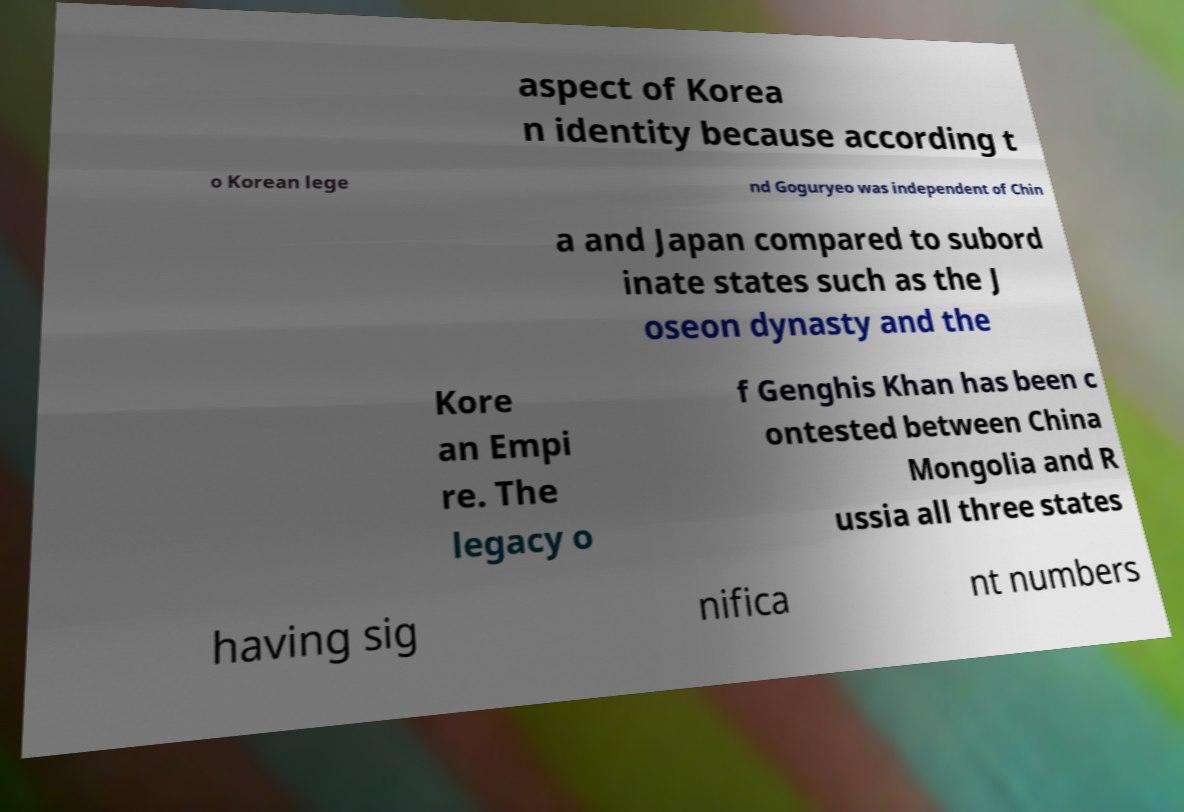Could you assist in decoding the text presented in this image and type it out clearly? aspect of Korea n identity because according t o Korean lege nd Goguryeo was independent of Chin a and Japan compared to subord inate states such as the J oseon dynasty and the Kore an Empi re. The legacy o f Genghis Khan has been c ontested between China Mongolia and R ussia all three states having sig nifica nt numbers 